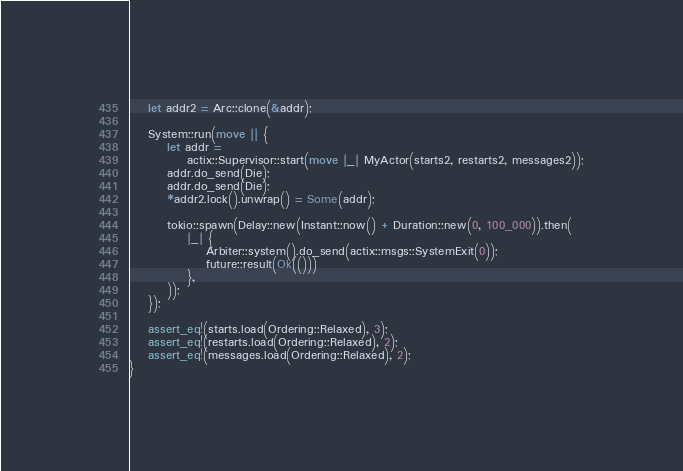Convert code to text. <code><loc_0><loc_0><loc_500><loc_500><_Rust_>    let addr2 = Arc::clone(&addr);

    System::run(move || {
        let addr =
            actix::Supervisor::start(move |_| MyActor(starts2, restarts2, messages2));
        addr.do_send(Die);
        addr.do_send(Die);
        *addr2.lock().unwrap() = Some(addr);

        tokio::spawn(Delay::new(Instant::now() + Duration::new(0, 100_000)).then(
            |_| {
                Arbiter::system().do_send(actix::msgs::SystemExit(0));
                future::result(Ok(()))
            },
        ));
    });

    assert_eq!(starts.load(Ordering::Relaxed), 3);
    assert_eq!(restarts.load(Ordering::Relaxed), 2);
    assert_eq!(messages.load(Ordering::Relaxed), 2);
}
</code> 